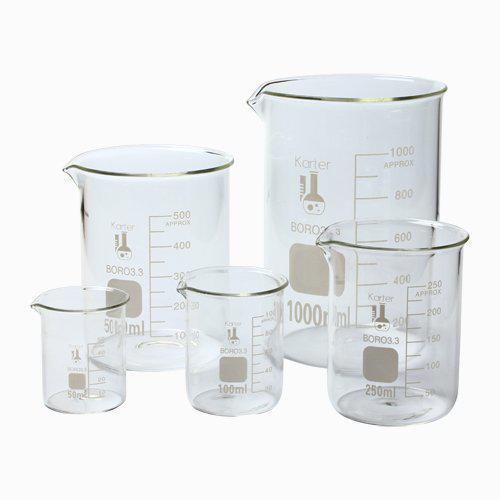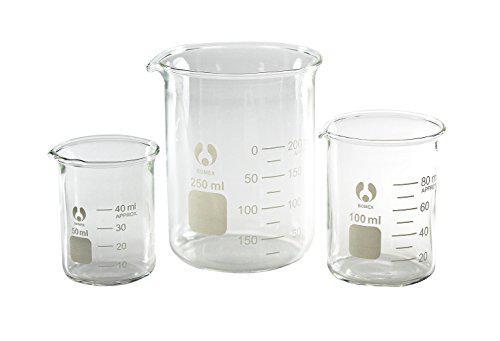The first image is the image on the left, the second image is the image on the right. For the images displayed, is the sentence "An image contains exactly three empty measuring cups, which are arranged in one horizontal row." factually correct? Answer yes or no. Yes. The first image is the image on the left, the second image is the image on the right. Analyze the images presented: Is the assertion "Exactly eight clear empty beakers are divided into two groupings, one with five beakers of different sizes and the other with three of different sizes." valid? Answer yes or no. Yes. 